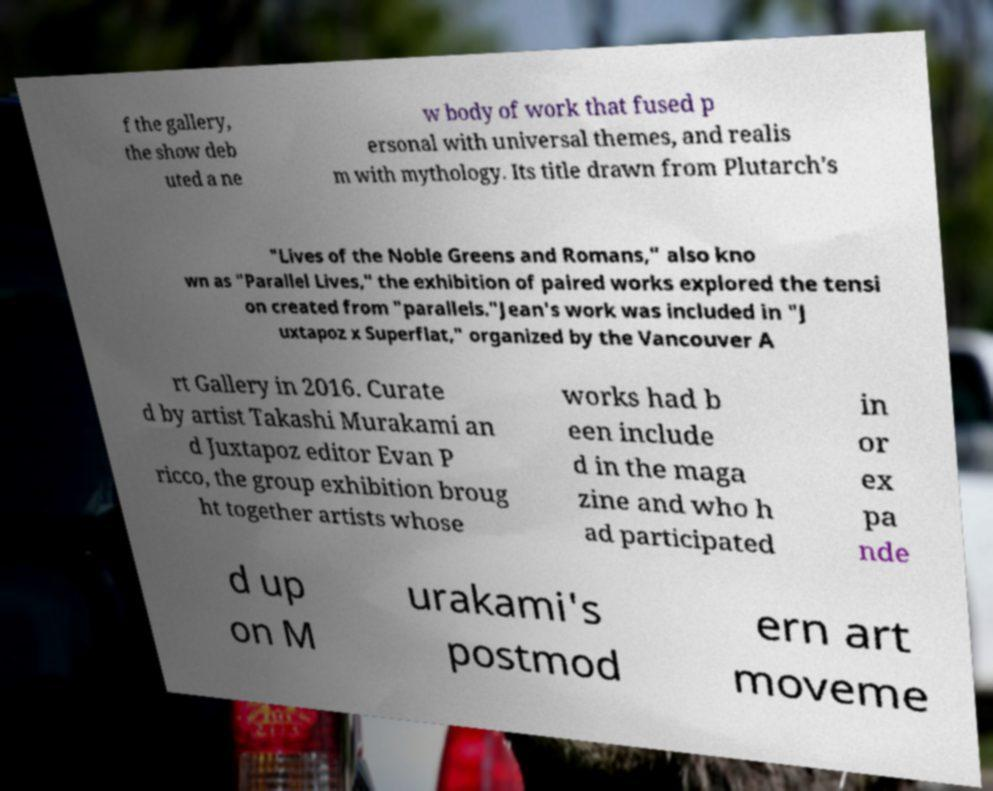I need the written content from this picture converted into text. Can you do that? f the gallery, the show deb uted a ne w body of work that fused p ersonal with universal themes, and realis m with mythology. Its title drawn from Plutarch's "Lives of the Noble Greens and Romans," also kno wn as "Parallel Lives," the exhibition of paired works explored the tensi on created from "parallels."Jean's work was included in "J uxtapoz x Superflat," organized by the Vancouver A rt Gallery in 2016. Curate d by artist Takashi Murakami an d Juxtapoz editor Evan P ricco, the group exhibition broug ht together artists whose works had b een include d in the maga zine and who h ad participated in or ex pa nde d up on M urakami's postmod ern art moveme 